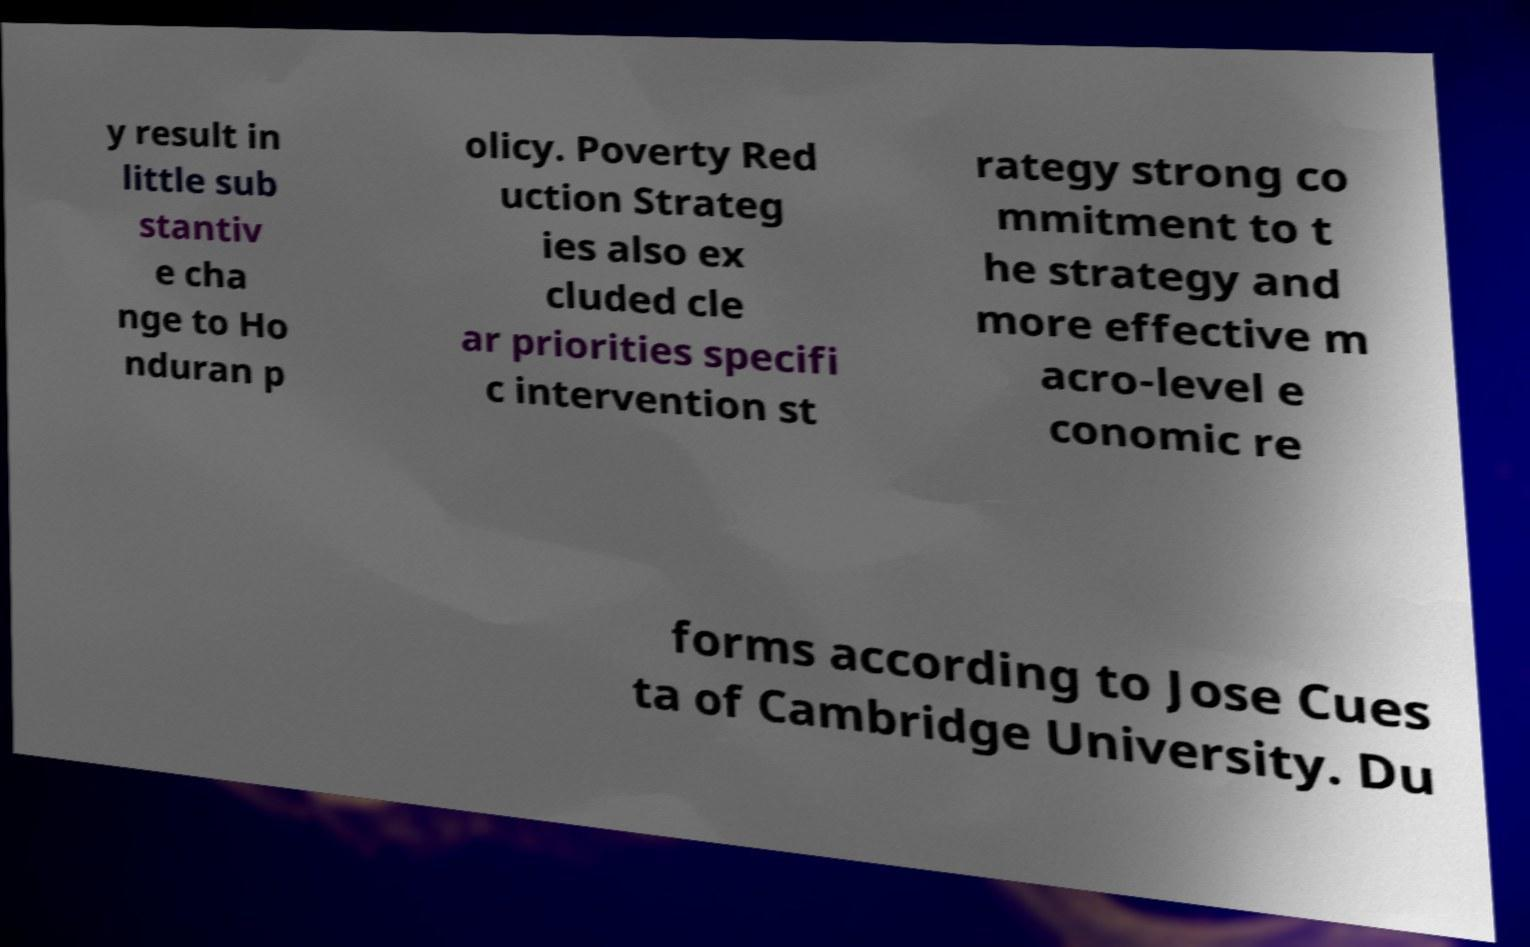I need the written content from this picture converted into text. Can you do that? y result in little sub stantiv e cha nge to Ho nduran p olicy. Poverty Red uction Strateg ies also ex cluded cle ar priorities specifi c intervention st rategy strong co mmitment to t he strategy and more effective m acro-level e conomic re forms according to Jose Cues ta of Cambridge University. Du 